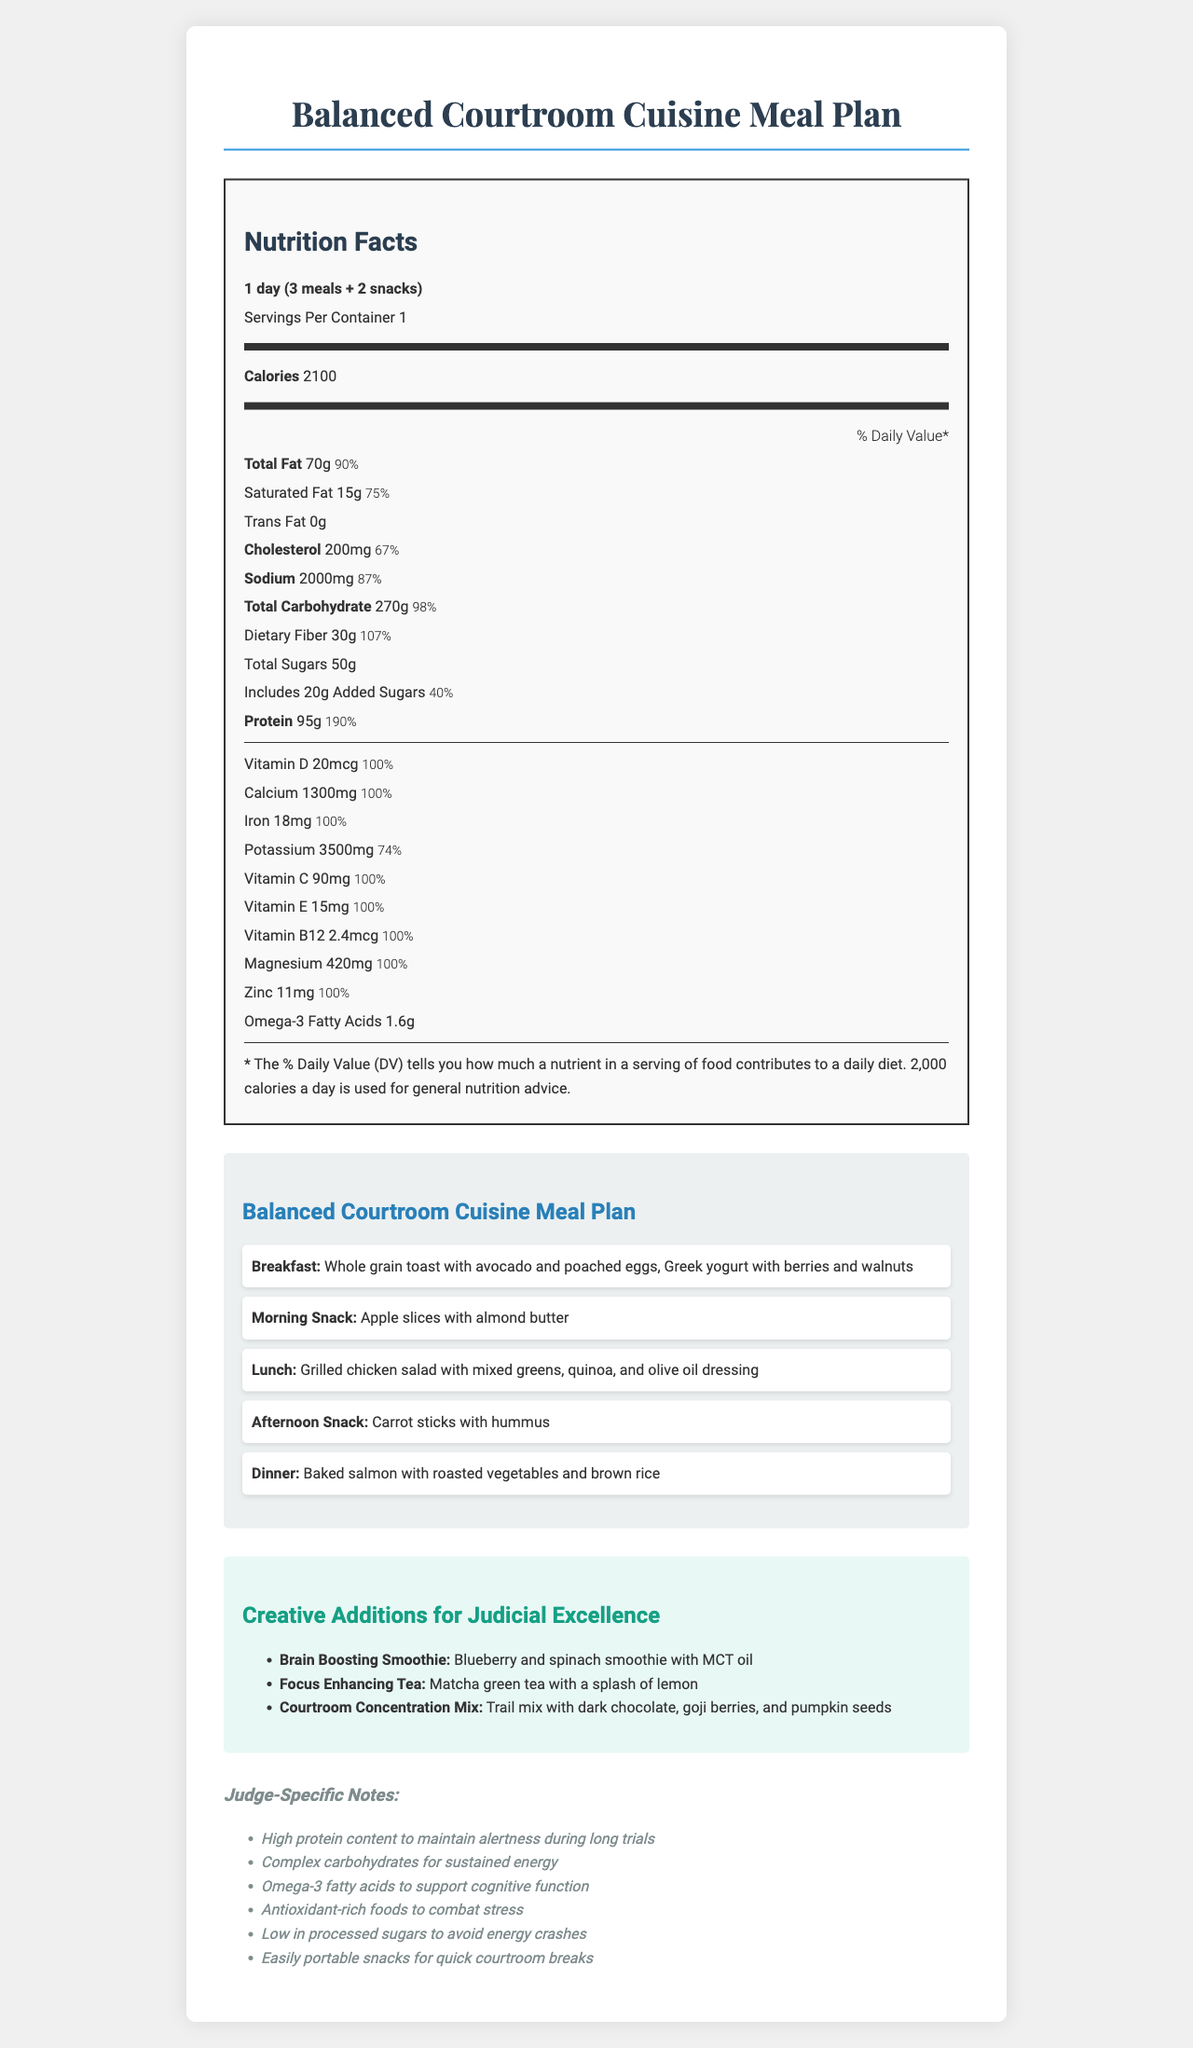what is the serving size for the Balanced Courtroom Cuisine Meal Plan? The serving size is mentioned at the top of the nutrition facts in the document.
Answer: 1 day (3 meals + 2 snacks) how many calories are in one serving of the meal plan? The calories are listed right after the serving information in the document.
Answer: 2100 what percentage of the Daily Value of dietary fiber does one serving provide? The document lists the percentage of Daily Value for dietary fiber as 107%.
Answer: 107% what is included in the afternoon snack of the meal plan? This is mentioned in the meal plan section under "Afternoon Snack".
Answer: Carrot sticks with hummus how much protein does a serving of the Balanced Courtroom Cuisine Meal Plan contain? The amount of protein is listed in the nutrition facts section.
Answer: 95g which of the following is a creative addition to the meal plan? A. Fruit Salad B. Brain Boosting Smoothie C. Protein Bar D. Spinach Wrap The Brain Boosting Smoothie is listed under the "Creative Additions" section.
Answer: B. Brain Boosting Smoothie what are the main components of the dinner in the meal plan? A. Baked tofu, quinoa, steamed broccoli B. Grilled chicken, mixed greens, brown rice C. Baked salmon, roasted vegetables, brown rice This is detailed in the meal plan section under "Dinner".
Answer: C. Baked salmon, roasted vegetables, brown rice does the meal plan contain any trans fats? Yes/No The nutrition facts state that the amount of trans fat is 0g.
Answer: No summarize the main goal of the Balanced Courtroom Cuisine Meal Plan. The document outlines a comprehensive meal plan curated for judges, detailing nutritional content, meal components, creative additions, and highlights specific notes focusing on high protein, complex carbohydrates, omega-3 fatty acids, antioxidants, and low processed sugars.
Answer: The main goal of the Balanced Courtroom Cuisine Meal Plan is to provide a nutritional breakdown designed to maintain alertness, sustain energy, and support cognitive function during long trial days, incorporating balanced meals and hydrating options. what percentage of the Daily Value of potassium does this meal plan provide? The percentage of the Daily Value for potassium is listed as 74% in the nutrition facts.
Answer: 74% I have a nut allergy. What should I avoid in this meal plan? The document does not specify whether the items contain nuts or if there's an alternative for people with nut allergies. It just lists meal components and creative additions without details on allergens.
Answer: Not enough information 